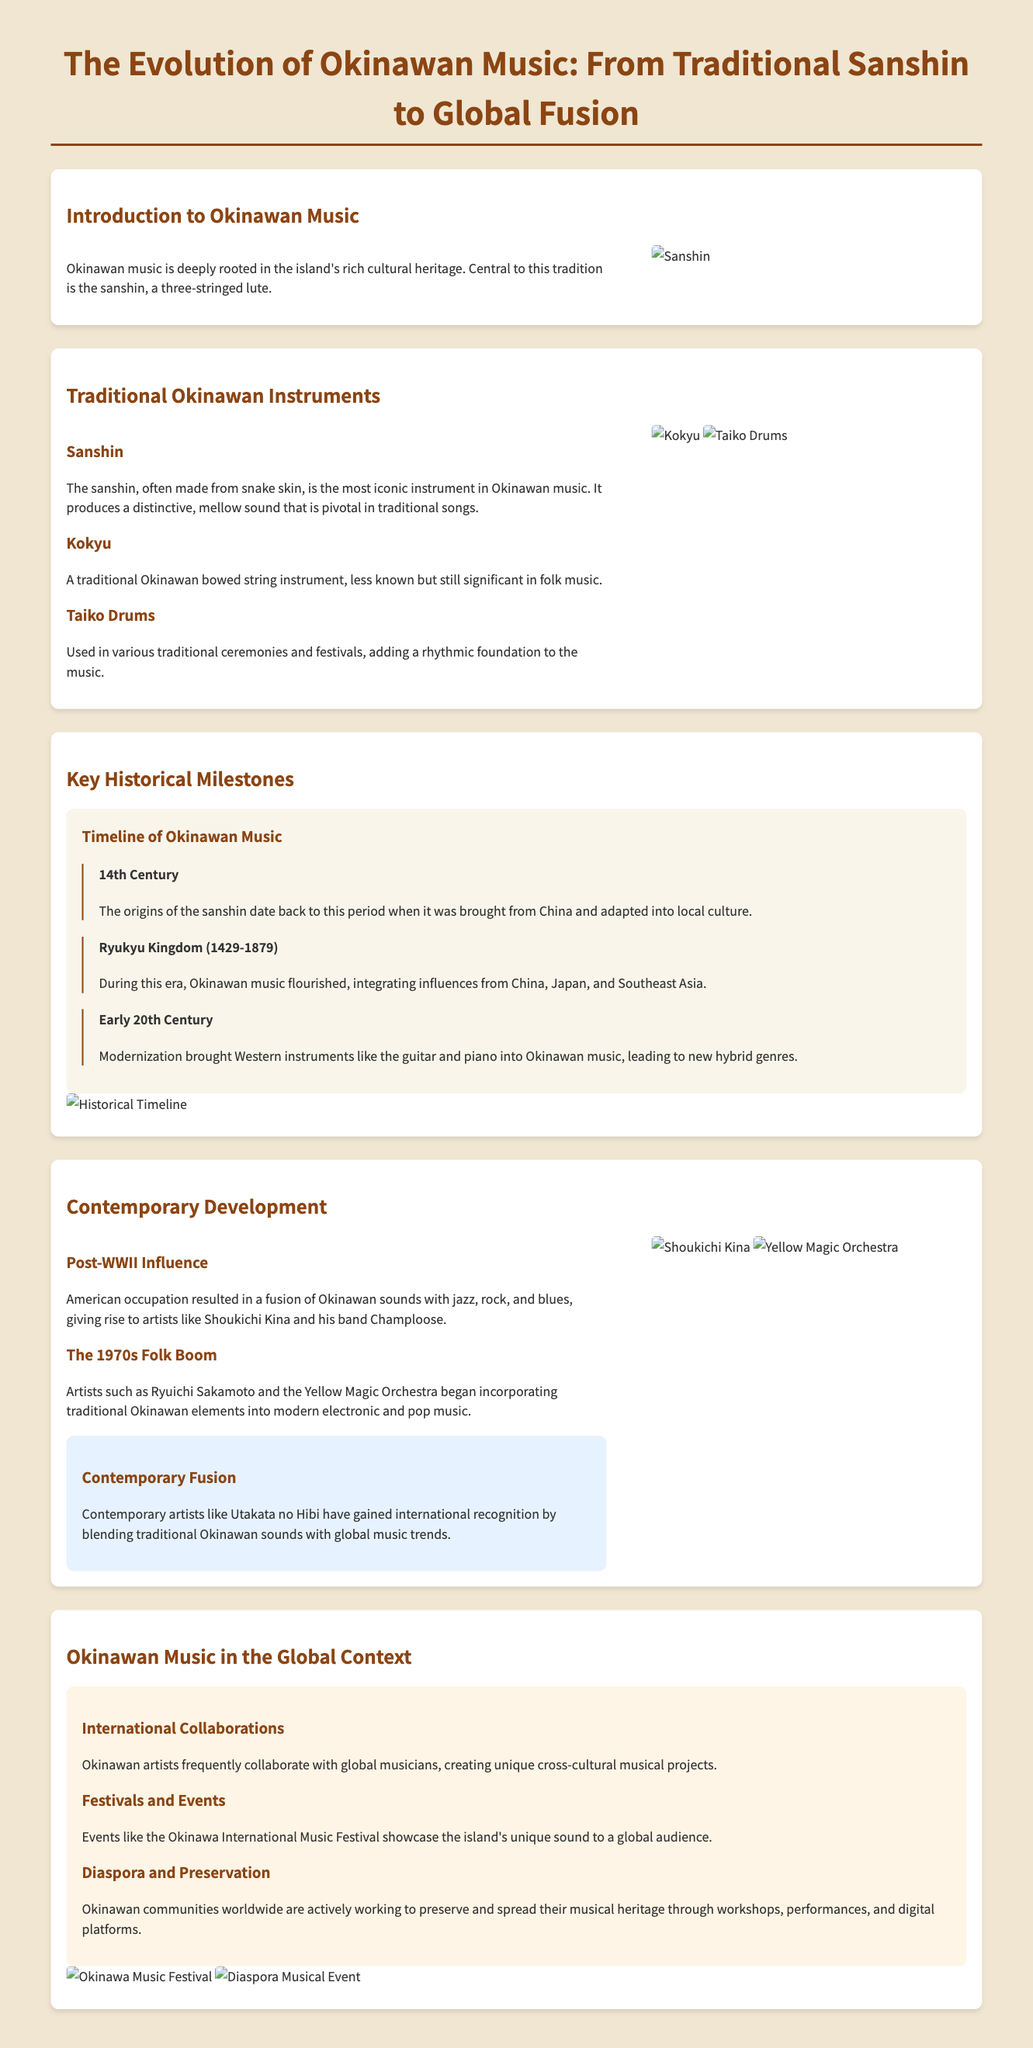What is the main traditional instrument in Okinawan music? The infographic identifies the sanshin as the central instrument in Okinawan music.
Answer: sanshin During which era did Okinawan music flourish? The document states that Okinawan music integrated various influences during the Ryukyu Kingdom period.
Answer: Ryukyu Kingdom (1429-1879) What western instruments were introduced to Okinawan music in the early 20th century? The document mentions the introduction of the guitar and piano as part of modernization.
Answer: guitar and piano Who is a notable artist from the post-WWII influence era? The infographic highlights Shoukichi Kina as a key figure emerging during this period.
Answer: Shoukichi Kina What was significant about the 1970s folk boom? The document states that contemporary artists began incorporating traditional Okinawan elements into modern music during this decade.
Answer: Incorporating traditional elements What is the purpose of the Okinawa International Music Festival? The document describes the festival as a platform for showcasing Okinawa's unique sound globally.
Answer: Showcase Okinawa's unique sound What instrument is less known but significant in folk music? The infographic refers to the kokyu as a traditional bowed string instrument that fits this description.
Answer: kokyu What type of projects do Okinawan artists engage in internationally? The document notes that they frequently collaborate on unique cross-cultural musical projects.
Answer: Cross-cultural musical projects What material is the sanshin traditionally made from? The infographic mentions that the sanshin is often made from snake skin.
Answer: snake skin 